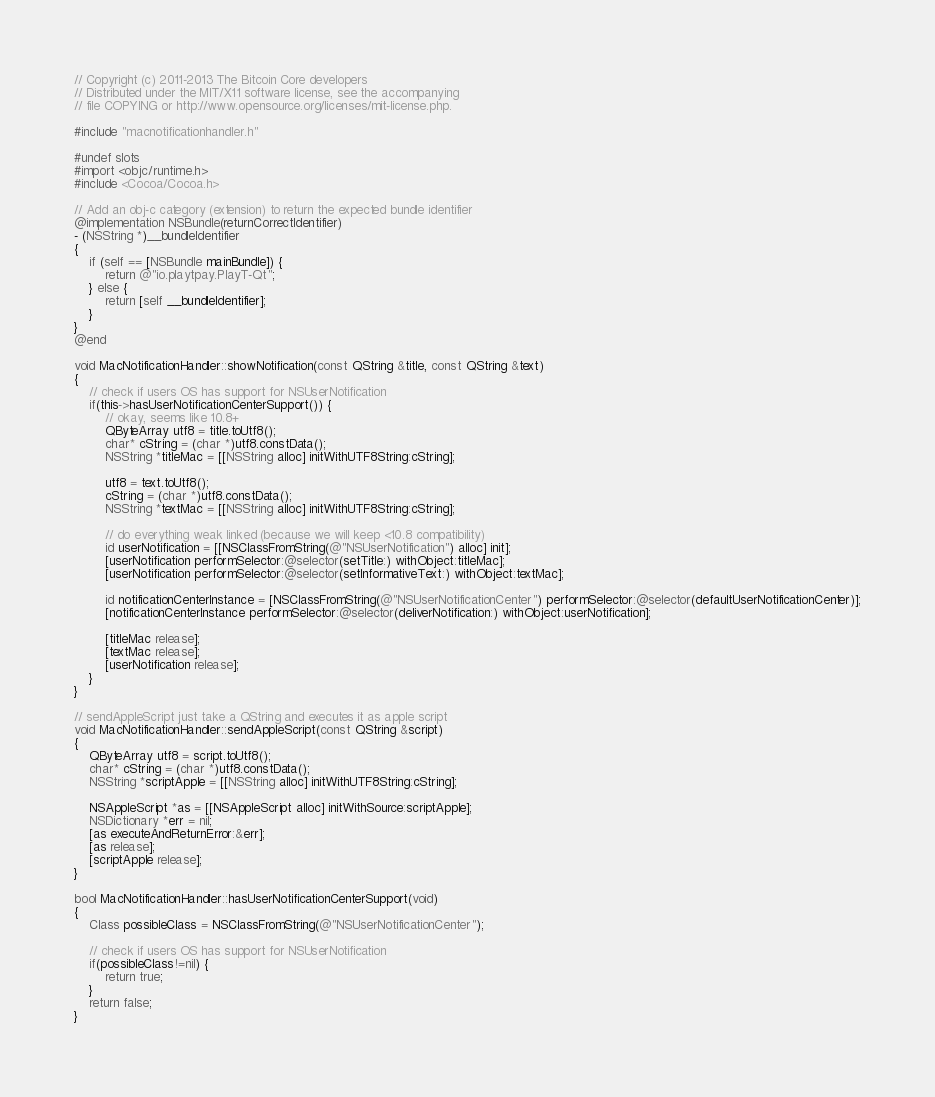Convert code to text. <code><loc_0><loc_0><loc_500><loc_500><_ObjectiveC_>// Copyright (c) 2011-2013 The Bitcoin Core developers
// Distributed under the MIT/X11 software license, see the accompanying
// file COPYING or http://www.opensource.org/licenses/mit-license.php.

#include "macnotificationhandler.h"

#undef slots
#import <objc/runtime.h>
#include <Cocoa/Cocoa.h>

// Add an obj-c category (extension) to return the expected bundle identifier
@implementation NSBundle(returnCorrectIdentifier)
- (NSString *)__bundleIdentifier
{
    if (self == [NSBundle mainBundle]) {
        return @"io.playtpay.PlayT-Qt";
    } else {
        return [self __bundleIdentifier];
    }
}
@end

void MacNotificationHandler::showNotification(const QString &title, const QString &text)
{
    // check if users OS has support for NSUserNotification
    if(this->hasUserNotificationCenterSupport()) {
        // okay, seems like 10.8+
        QByteArray utf8 = title.toUtf8();
        char* cString = (char *)utf8.constData();
        NSString *titleMac = [[NSString alloc] initWithUTF8String:cString];

        utf8 = text.toUtf8();
        cString = (char *)utf8.constData();
        NSString *textMac = [[NSString alloc] initWithUTF8String:cString];

        // do everything weak linked (because we will keep <10.8 compatibility)
        id userNotification = [[NSClassFromString(@"NSUserNotification") alloc] init];
        [userNotification performSelector:@selector(setTitle:) withObject:titleMac];
        [userNotification performSelector:@selector(setInformativeText:) withObject:textMac];

        id notificationCenterInstance = [NSClassFromString(@"NSUserNotificationCenter") performSelector:@selector(defaultUserNotificationCenter)];
        [notificationCenterInstance performSelector:@selector(deliverNotification:) withObject:userNotification];

        [titleMac release];
        [textMac release];
        [userNotification release];
    }
}

// sendAppleScript just take a QString and executes it as apple script
void MacNotificationHandler::sendAppleScript(const QString &script)
{
    QByteArray utf8 = script.toUtf8();
    char* cString = (char *)utf8.constData();
    NSString *scriptApple = [[NSString alloc] initWithUTF8String:cString];

    NSAppleScript *as = [[NSAppleScript alloc] initWithSource:scriptApple];
    NSDictionary *err = nil;
    [as executeAndReturnError:&err];
    [as release];
    [scriptApple release];
}

bool MacNotificationHandler::hasUserNotificationCenterSupport(void)
{
    Class possibleClass = NSClassFromString(@"NSUserNotificationCenter");

    // check if users OS has support for NSUserNotification
    if(possibleClass!=nil) {
        return true;
    }
    return false;
}

</code> 